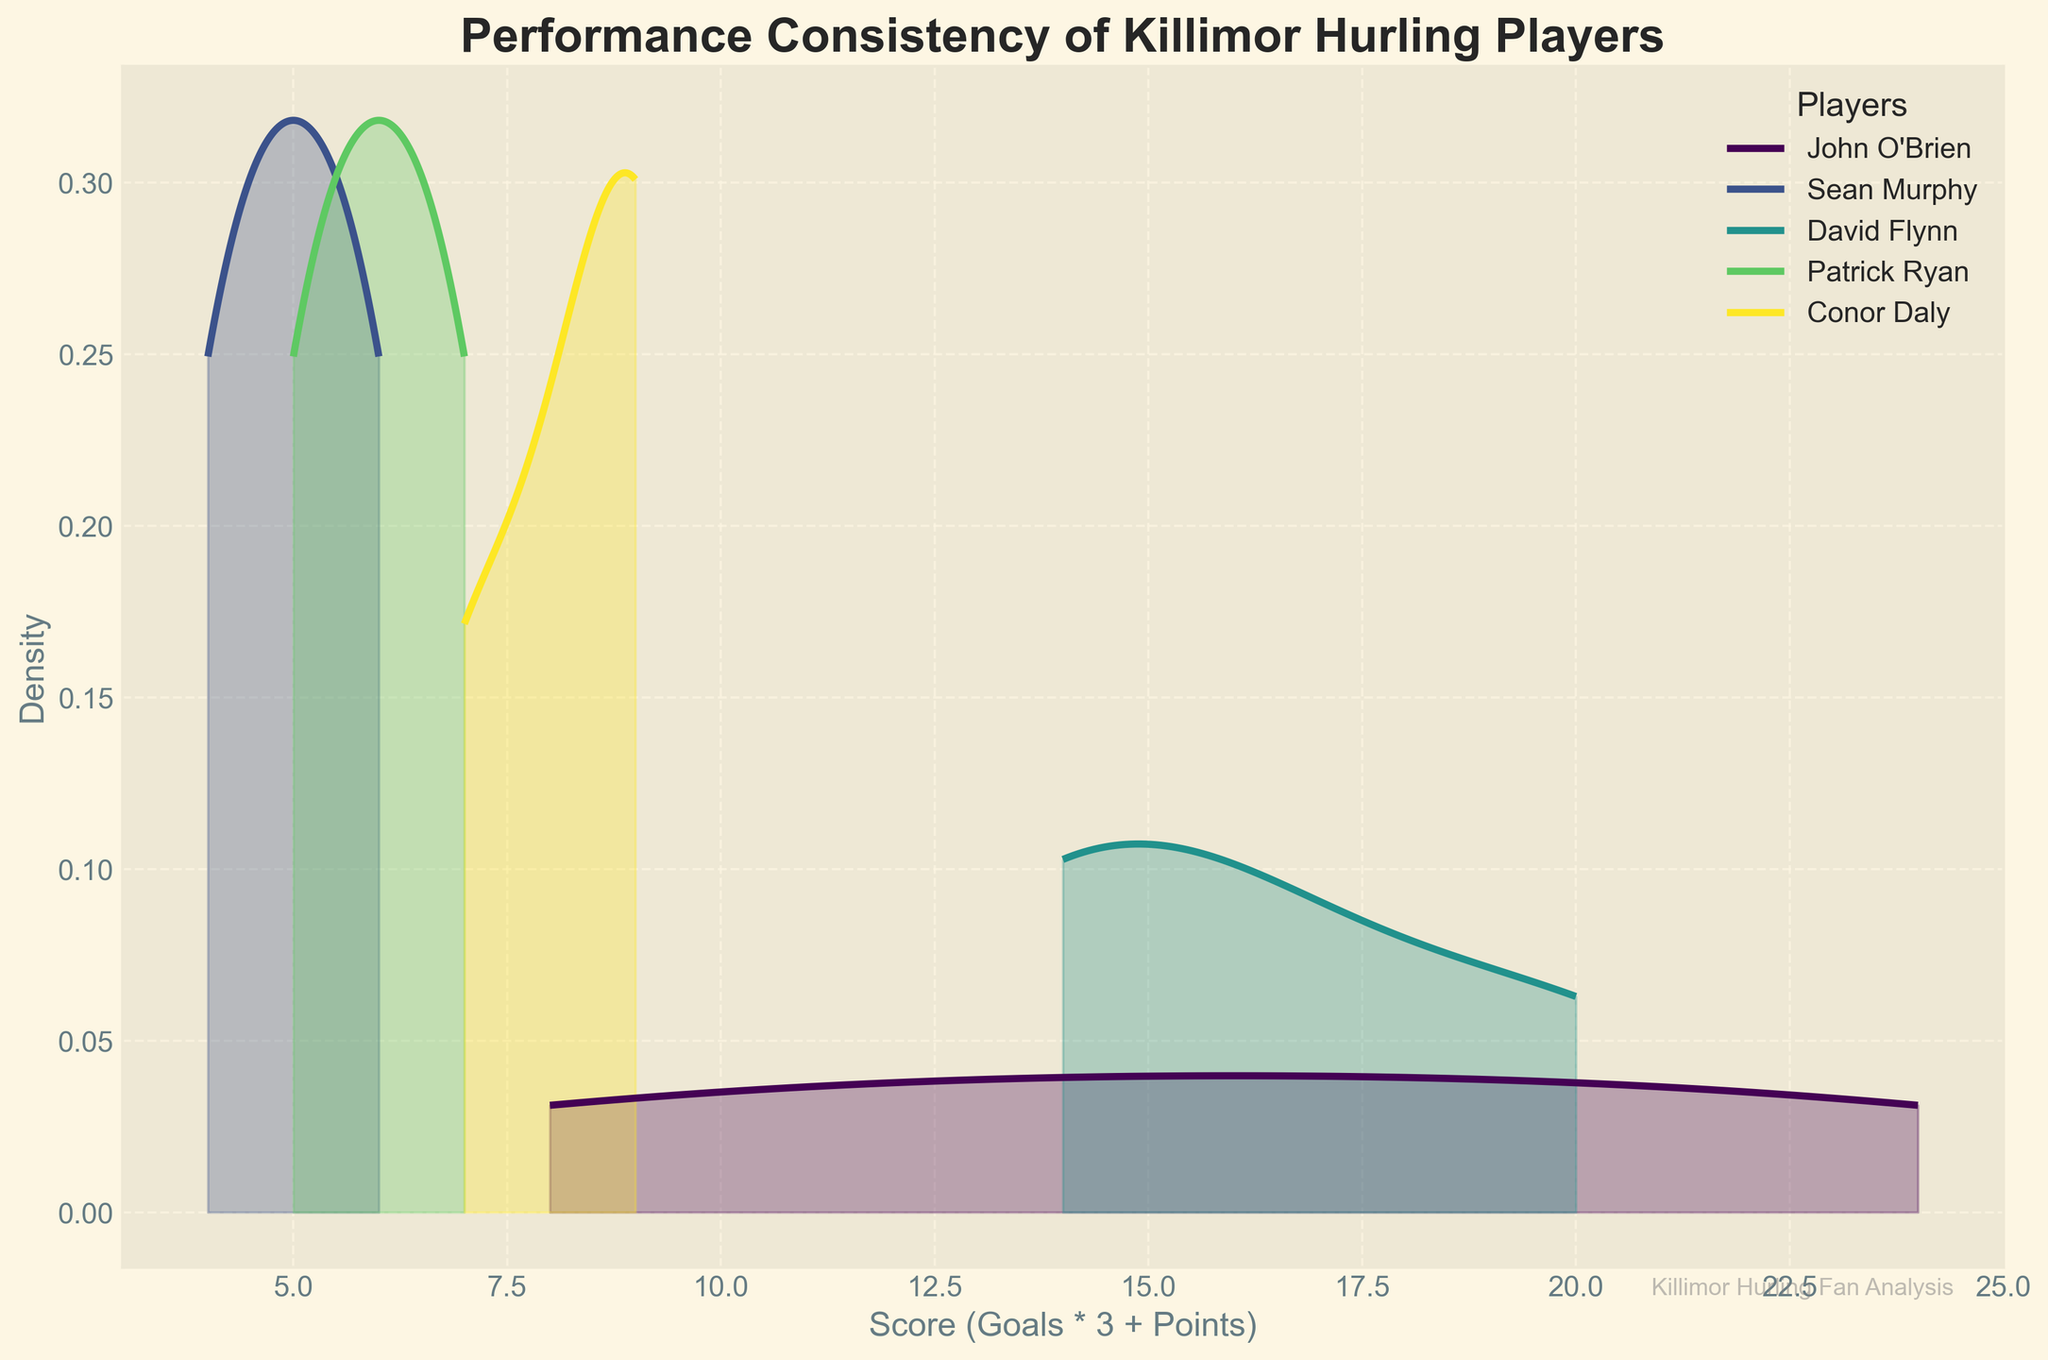What is the title of the plot? The title is displayed at the top of the plot and reads "Performance Consistency of Killimor Hurling Players".
Answer: Performance Consistency of Killimor Hurling Players What is the x-axis label? The x-axis label is given below the x-axis and reads "Score (Goals * 3 + Points)".
Answer: Score (Goals * 3 + Points) Which player has the highest peak density in their KDE plot? By looking at the heights of the peaks, David Flynn's plot appears to be the highest, meaning his scores were consistently high.
Answer: David Flynn What is the main color scheme used in the plot? The plot uses a color gradient from the viridis color map, which ranges from shades of purple to yellow-green.
Answer: viridis color map What score range does John O’Brien’s KDE plot cover? The KDE plot for John O’Brien spans from around 8 to 24 on the x-axis.
Answer: 8 to 24 How does the density distribution of Sean Murphy compare to Conor Daly? Sean Murphy’s density distribution is lower and more consistent around lower scores compared to Conor Daly, indicating less variation in performance.
Answer: Sean Murphy has a lower, more consistent density Which player shows the widest range of scores? David Flynn’s KDE plot covers the widest range, from about 14 to 30, indicating a wider range of scores across matches.
Answer: David Flynn What is the maximum score on the x-axis? The maximum score on the x-axis, where the distribution tails off, is around 30.
Answer: 30 Who has the most consistent performance according to their KDE plot spread? Patrick Ryan's KDE plot has the narrowest spread, suggesting the most consistent performance.
Answer: Patrick Ryan 